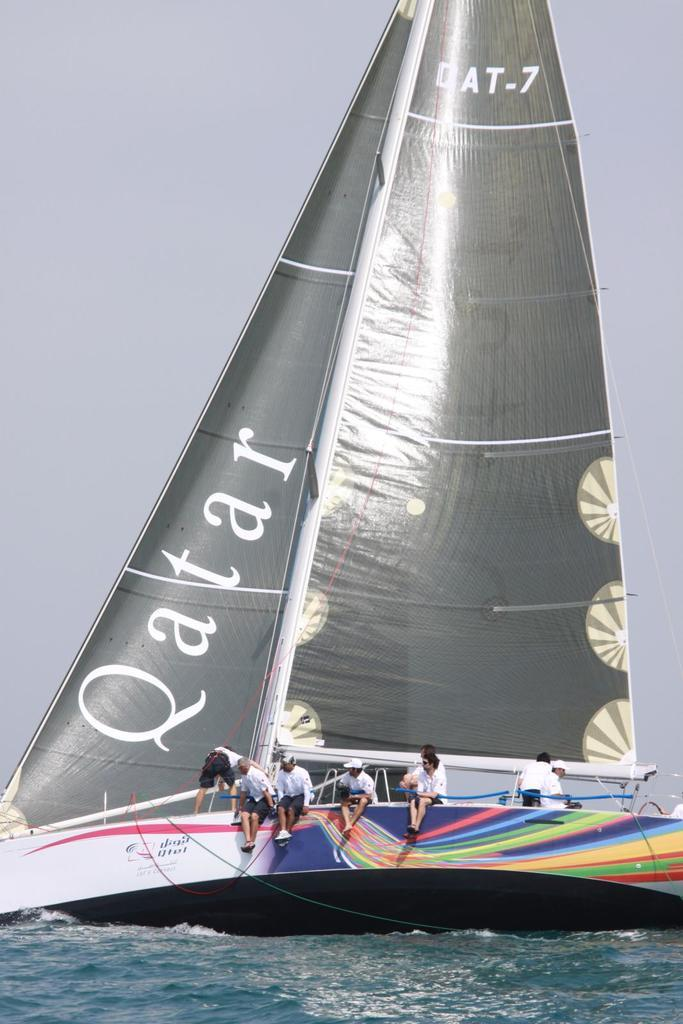What are the people in the image doing? The people in the image are sitting and standing on a boat. Where is the boat located? The boat is on the water. What can be seen in the background of the image? The sky is visible behind the boat. What type of caption is written on the boat in the image? There is no caption visible on the boat in the image. Is there a fight happening on the boat in the image? There is no indication of a fight in the image; people are simply sitting and standing on the boat. 